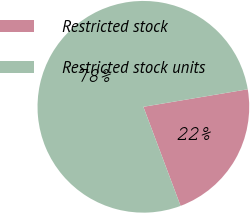<chart> <loc_0><loc_0><loc_500><loc_500><pie_chart><fcel>Restricted stock<fcel>Restricted stock units<nl><fcel>21.93%<fcel>78.07%<nl></chart> 